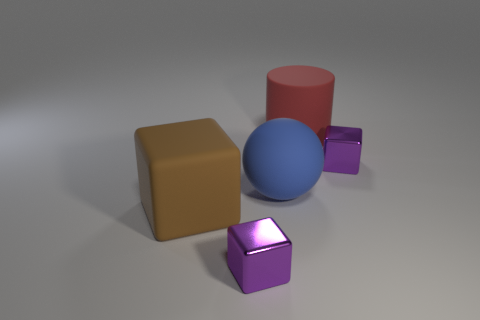Is there any other thing that is the same shape as the red matte thing?
Provide a short and direct response. No. Are there fewer red matte cylinders than small rubber cubes?
Provide a short and direct response. No. What number of other things are the same shape as the blue rubber thing?
Give a very brief answer. 0. What number of blue things are cylinders or big blocks?
Keep it short and to the point. 0. What is the size of the cube on the right side of the shiny thing in front of the large blue thing?
Give a very brief answer. Small. What number of blue matte spheres are the same size as the cylinder?
Provide a short and direct response. 1. Does the blue thing have the same size as the rubber cylinder?
Your response must be concise. Yes. There is a thing that is both on the left side of the big ball and on the right side of the big brown thing; how big is it?
Make the answer very short. Small. Are there more blue matte things to the right of the large blue rubber object than small purple cubes left of the large cylinder?
Your answer should be compact. No. There is a tiny block that is on the left side of the big red thing; is its color the same as the big cube?
Your response must be concise. No. 